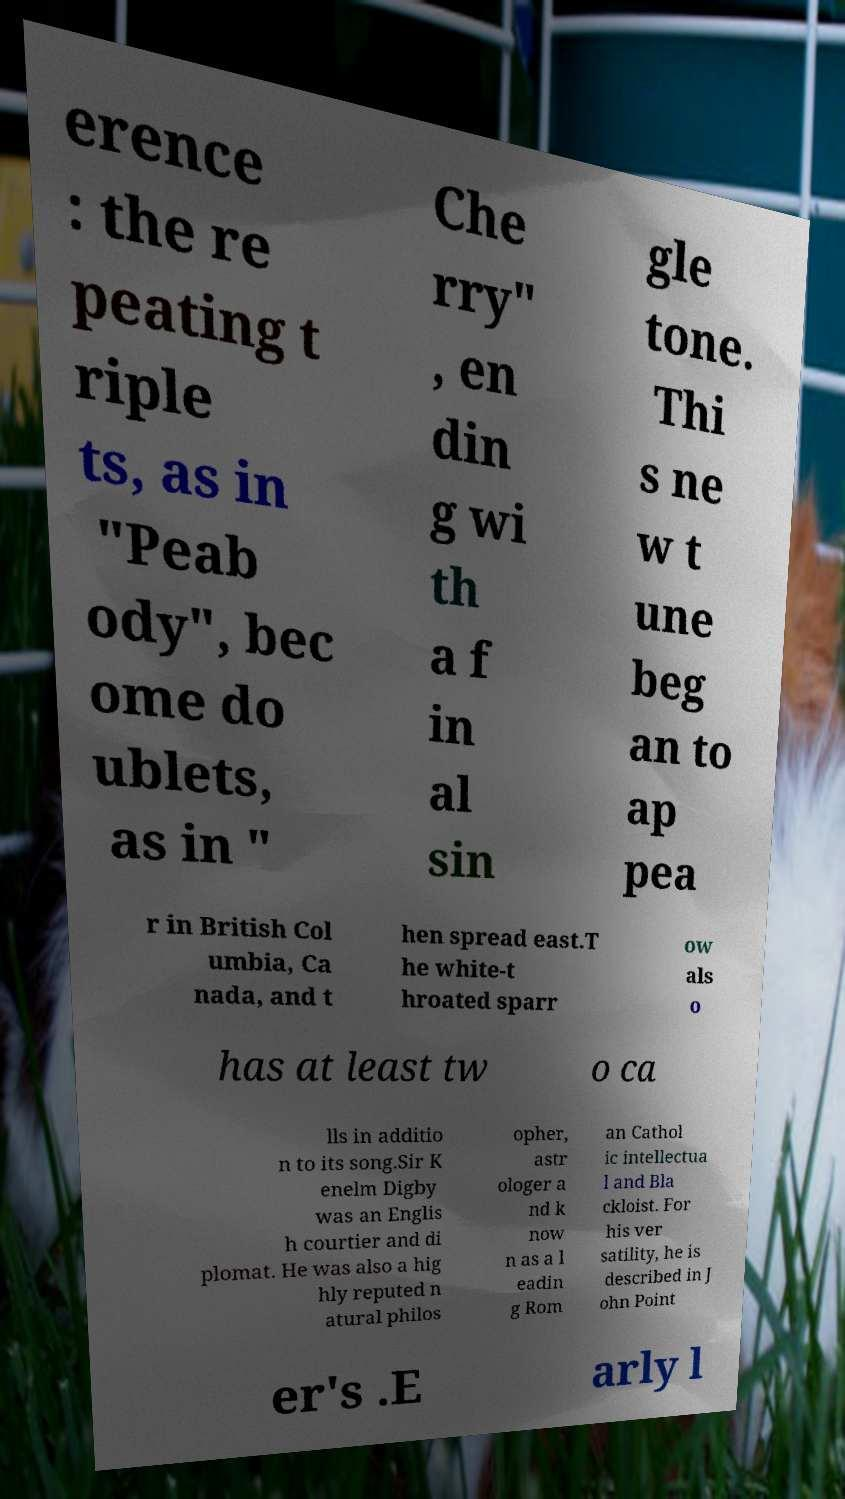I need the written content from this picture converted into text. Can you do that? erence : the re peating t riple ts, as in "Peab ody", bec ome do ublets, as in " Che rry" , en din g wi th a f in al sin gle tone. Thi s ne w t une beg an to ap pea r in British Col umbia, Ca nada, and t hen spread east.T he white-t hroated sparr ow als o has at least tw o ca lls in additio n to its song.Sir K enelm Digby was an Englis h courtier and di plomat. He was also a hig hly reputed n atural philos opher, astr ologer a nd k now n as a l eadin g Rom an Cathol ic intellectua l and Bla ckloist. For his ver satility, he is described in J ohn Point er's .E arly l 